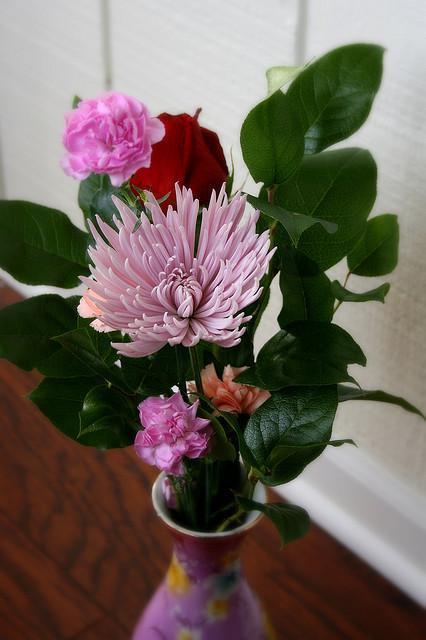How many flowers are in the pitcher?
Give a very brief answer. 5. How many vases are there?
Give a very brief answer. 1. How many boats in the water?
Give a very brief answer. 0. 